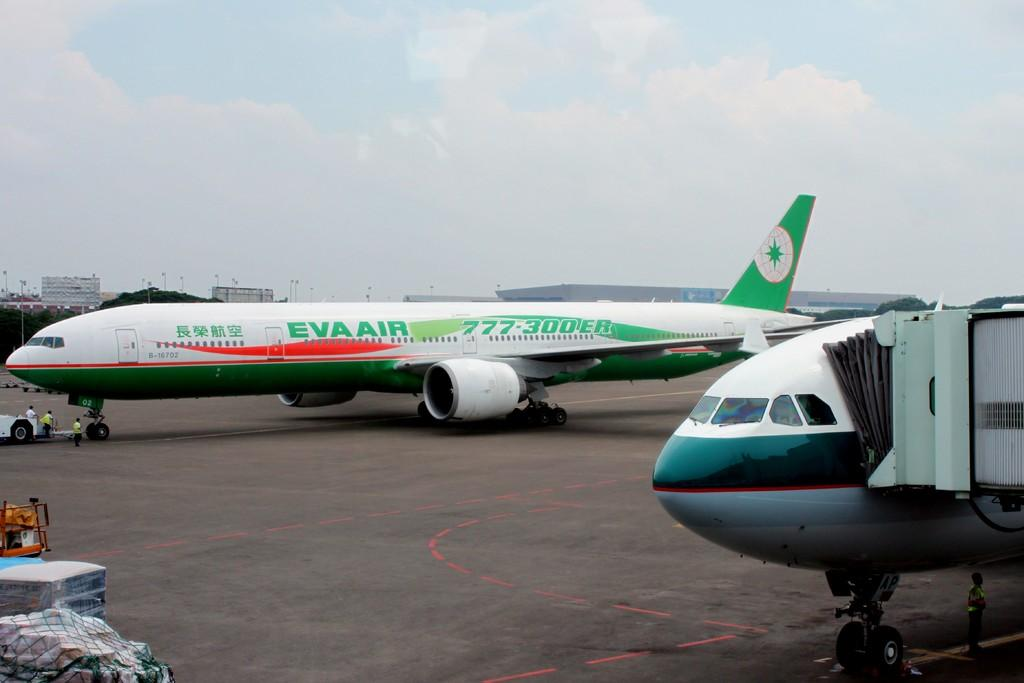<image>
Relay a brief, clear account of the picture shown. The passengers flying with Eva Air will be traveling in a 777-300 ER type airplane. 